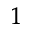<formula> <loc_0><loc_0><loc_500><loc_500>^ { 1 }</formula> 